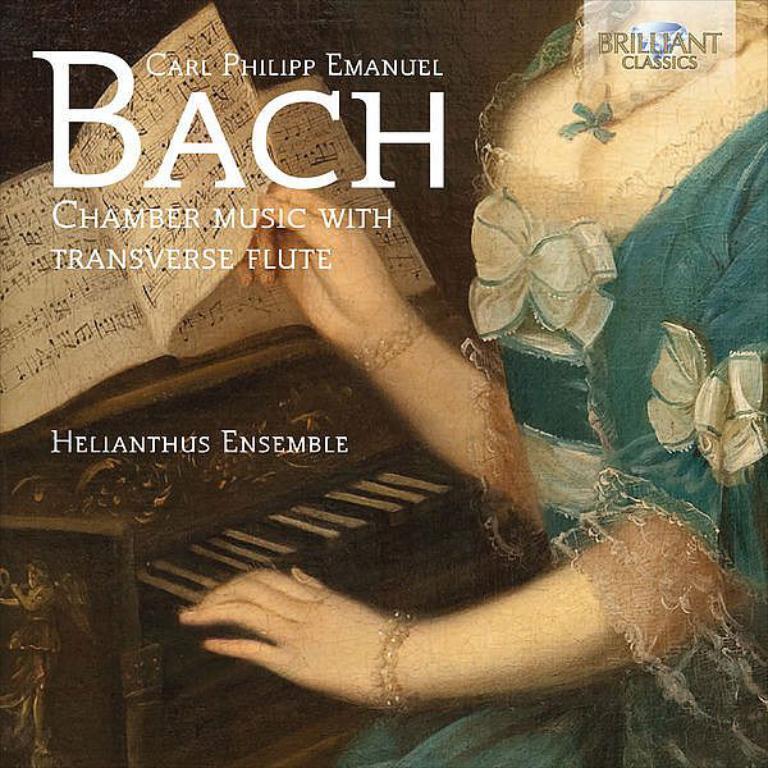Can you describe this image briefly? In this image, we can see a person who´is face is not visible holding a page with her hand. There is a piano in the bottom left of the image. 